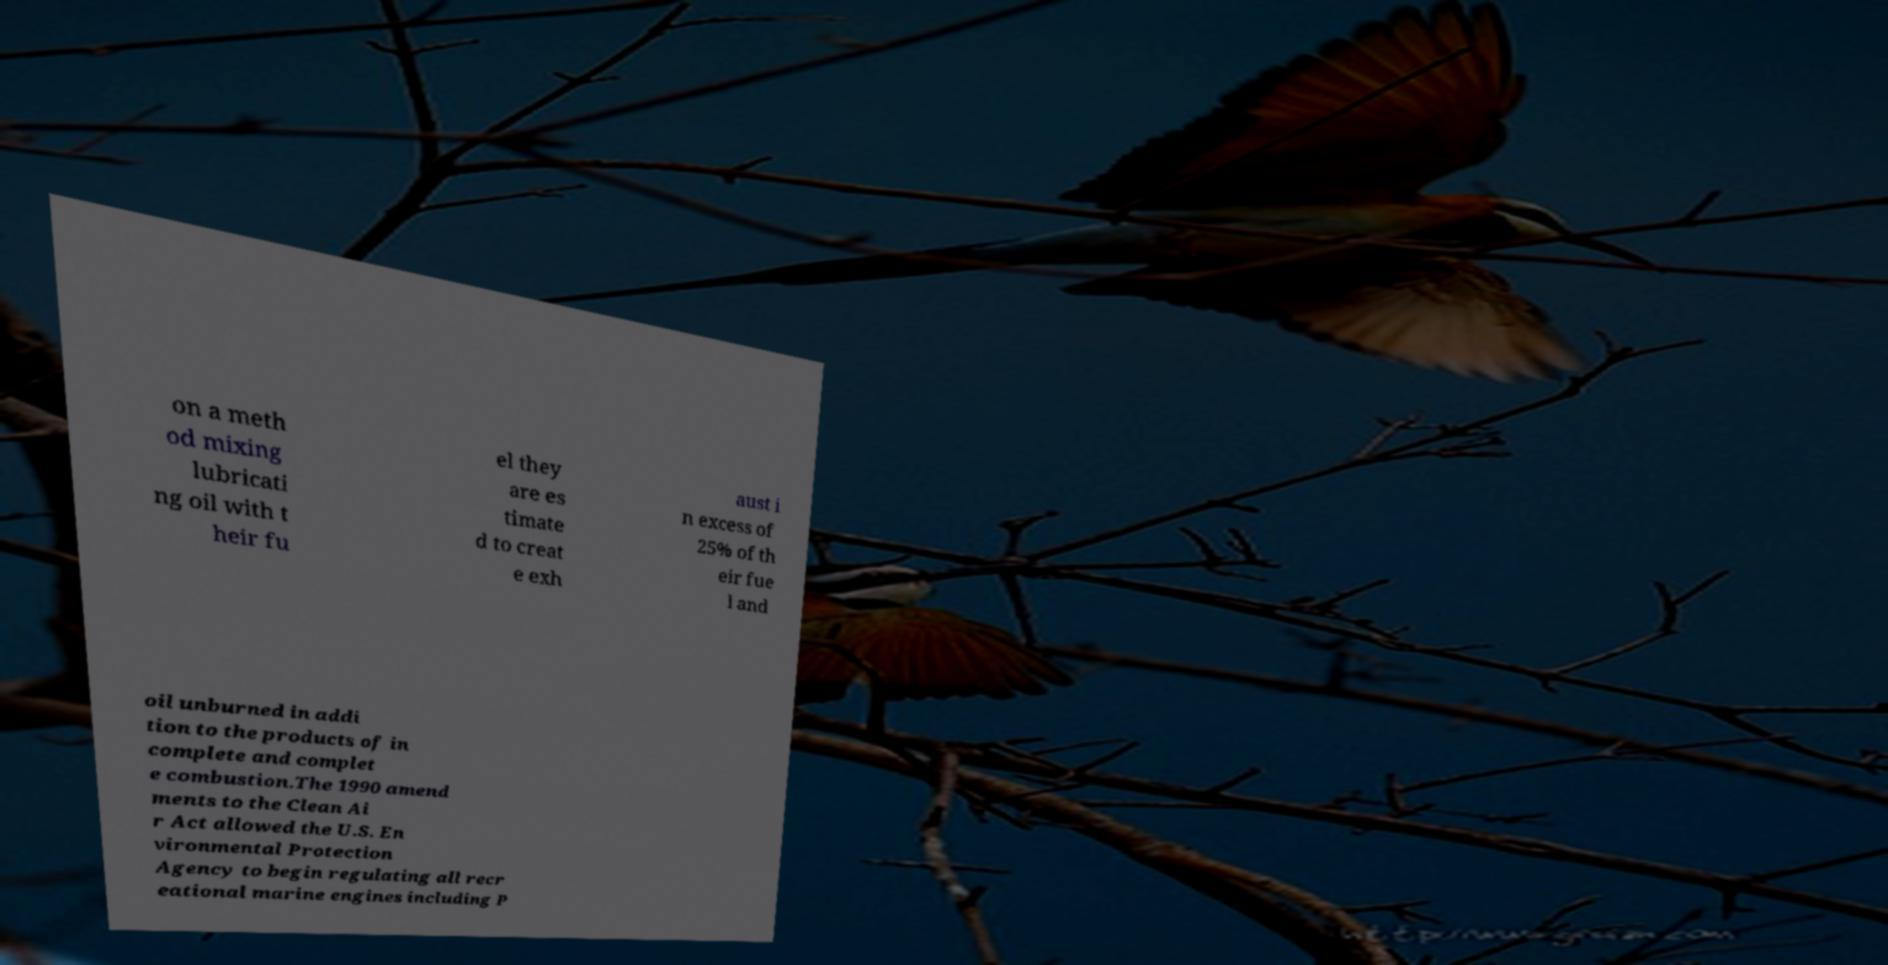There's text embedded in this image that I need extracted. Can you transcribe it verbatim? on a meth od mixing lubricati ng oil with t heir fu el they are es timate d to creat e exh aust i n excess of 25% of th eir fue l and oil unburned in addi tion to the products of in complete and complet e combustion.The 1990 amend ments to the Clean Ai r Act allowed the U.S. En vironmental Protection Agency to begin regulating all recr eational marine engines including P 